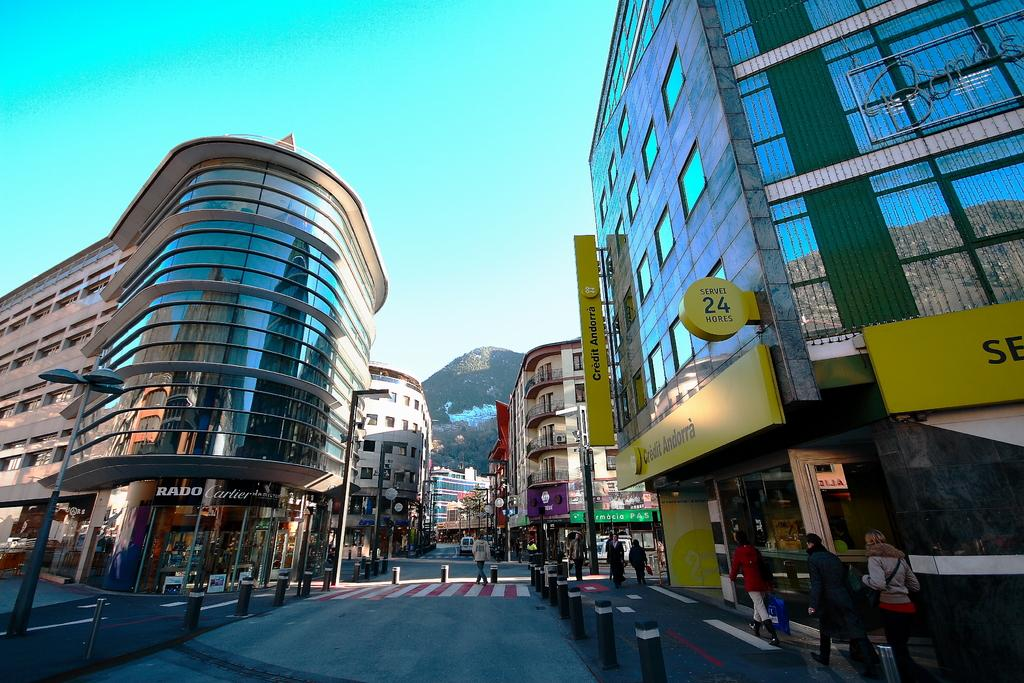What type of buildings are visible in the image? There are buildings with glass windows in the image. What is displayed on the buildings? There are hoardings on the buildings. Are there any people present in the image? Yes, there are people in front of the buildings. What type of brush can be seen in the hands of the people in the image? There is no brush visible in the hands of the people in the image. What kind of lunch is being served in the image? There is no lunch being served in the image; it primarily features buildings with hoardings and people in front of them. 